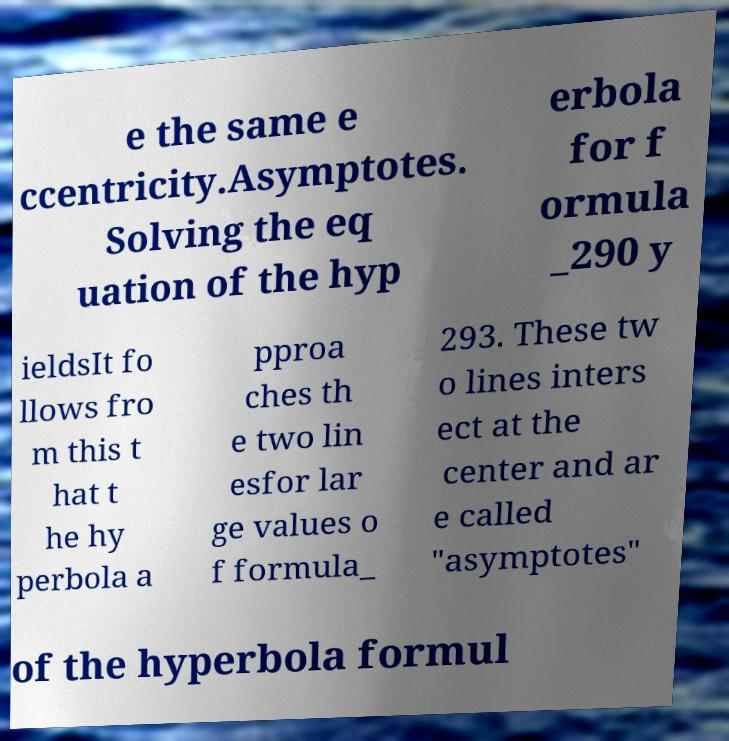For documentation purposes, I need the text within this image transcribed. Could you provide that? e the same e ccentricity.Asymptotes. Solving the eq uation of the hyp erbola for f ormula _290 y ieldsIt fo llows fro m this t hat t he hy perbola a pproa ches th e two lin esfor lar ge values o f formula_ 293. These tw o lines inters ect at the center and ar e called "asymptotes" of the hyperbola formul 